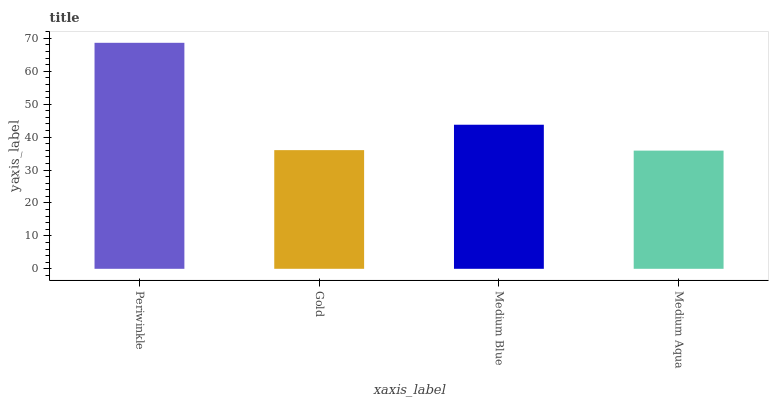Is Periwinkle the maximum?
Answer yes or no. Yes. Is Gold the minimum?
Answer yes or no. No. Is Gold the maximum?
Answer yes or no. No. Is Periwinkle greater than Gold?
Answer yes or no. Yes. Is Gold less than Periwinkle?
Answer yes or no. Yes. Is Gold greater than Periwinkle?
Answer yes or no. No. Is Periwinkle less than Gold?
Answer yes or no. No. Is Medium Blue the high median?
Answer yes or no. Yes. Is Gold the low median?
Answer yes or no. Yes. Is Medium Aqua the high median?
Answer yes or no. No. Is Medium Blue the low median?
Answer yes or no. No. 